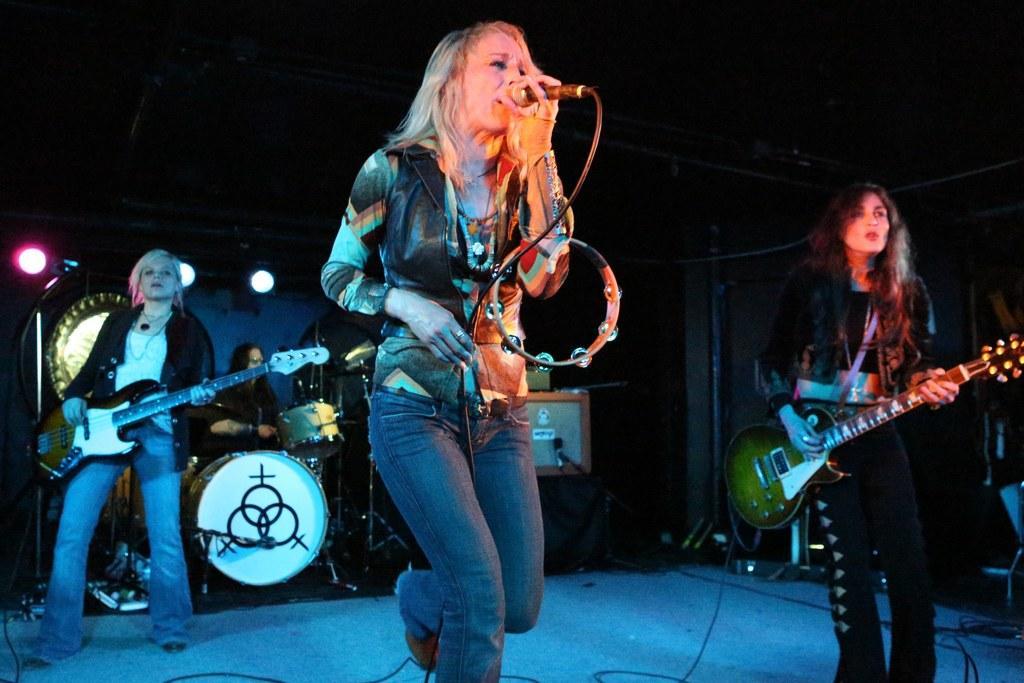Please provide a concise description of this image. There are few people on the stage performing by playing musical instruments and this woman is singing on mic. 